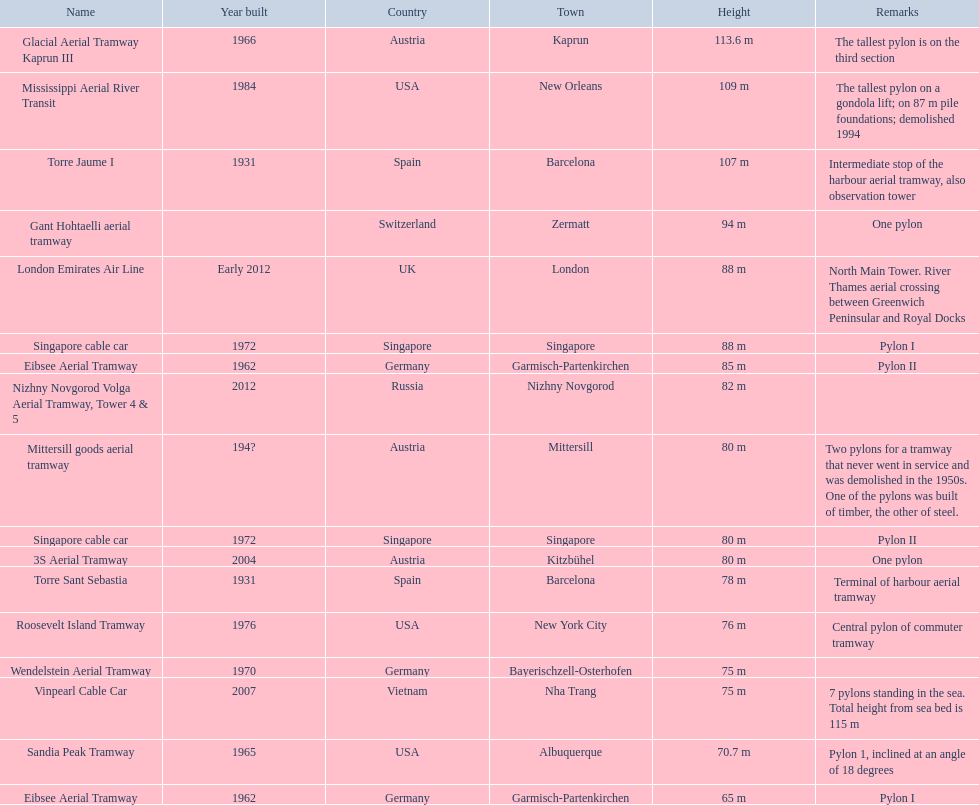Which elevator reaches the second greatest height? Mississippi Aerial River Transit. What is the height's value? 109 m. 